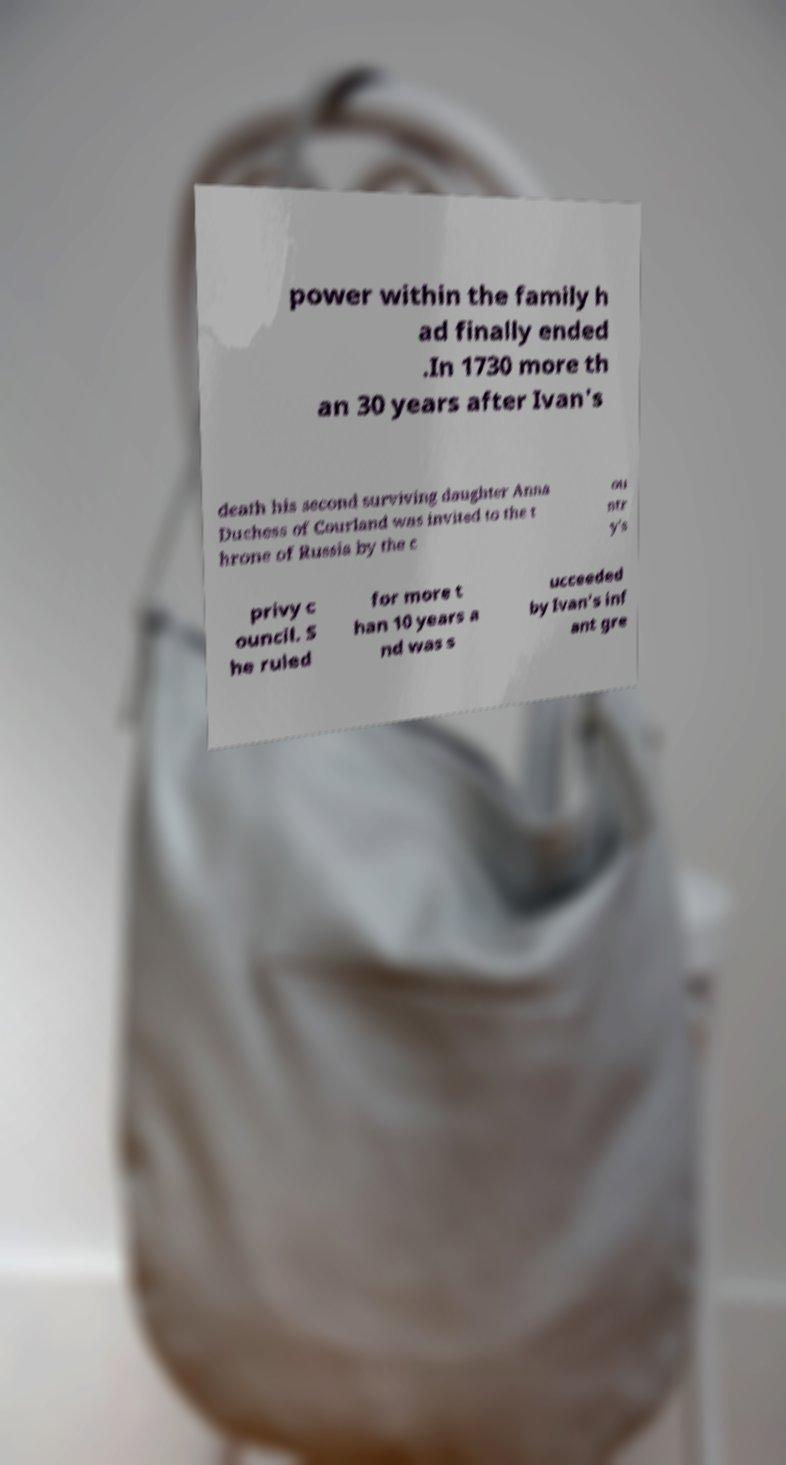Can you read and provide the text displayed in the image?This photo seems to have some interesting text. Can you extract and type it out for me? power within the family h ad finally ended .In 1730 more th an 30 years after Ivan's death his second surviving daughter Anna Duchess of Courland was invited to the t hrone of Russia by the c ou ntr y's privy c ouncil. S he ruled for more t han 10 years a nd was s ucceeded by Ivan's inf ant gre 